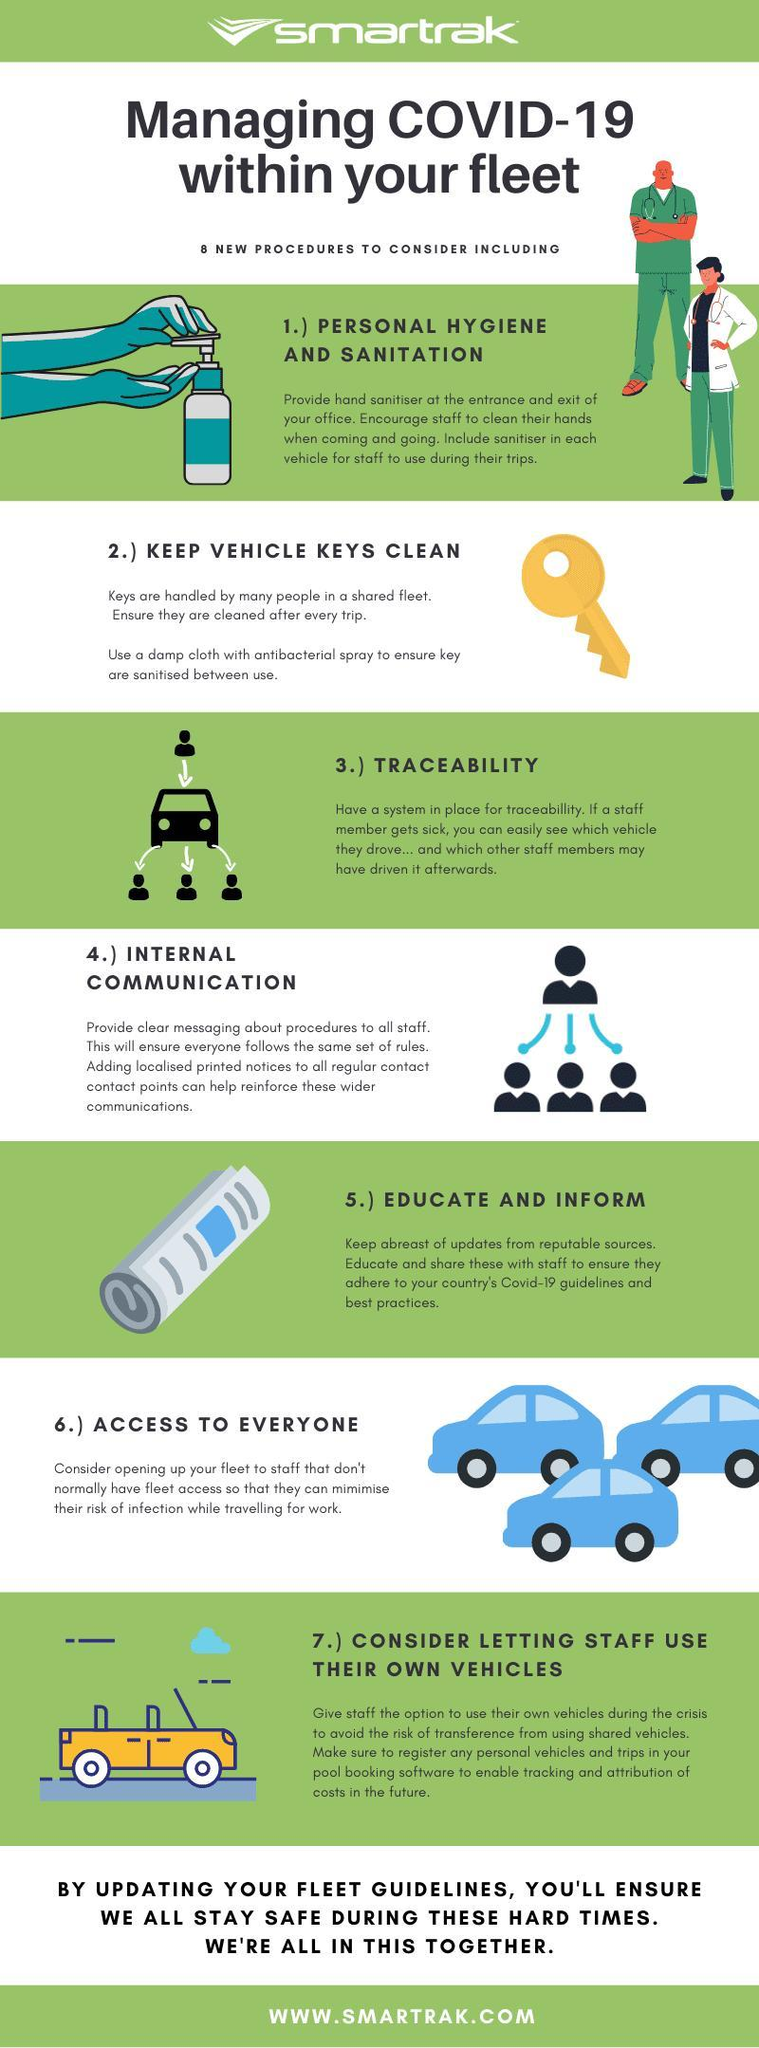what is the colour of the key, yellow or red
Answer the question with a short phrase. yellow what procedure is covered by providing hand sanitiser at the entrance and exit personal hygiene and sanitation 